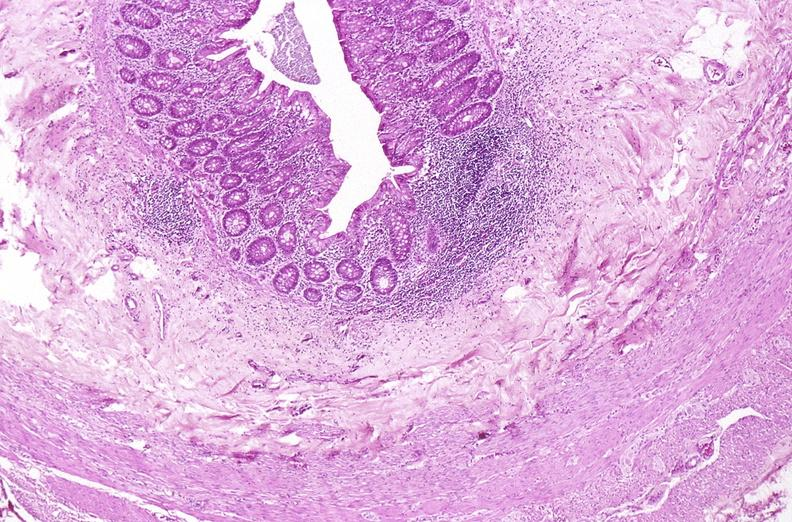what is present?
Answer the question using a single word or phrase. Gastrointestinal 